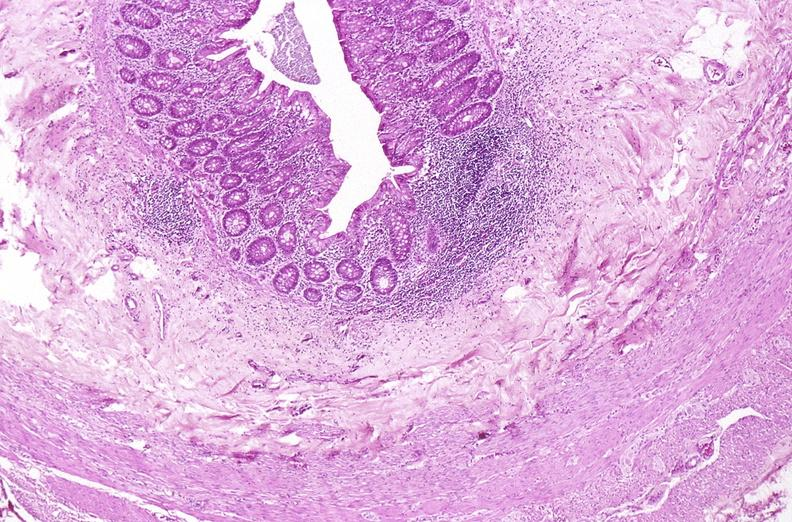what is present?
Answer the question using a single word or phrase. Gastrointestinal 